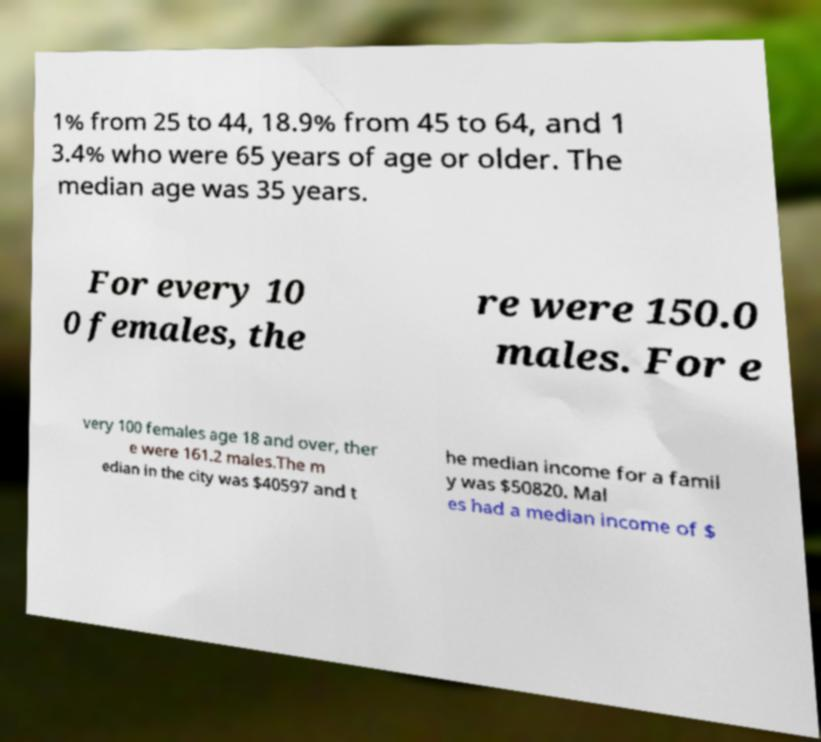There's text embedded in this image that I need extracted. Can you transcribe it verbatim? 1% from 25 to 44, 18.9% from 45 to 64, and 1 3.4% who were 65 years of age or older. The median age was 35 years. For every 10 0 females, the re were 150.0 males. For e very 100 females age 18 and over, ther e were 161.2 males.The m edian in the city was $40597 and t he median income for a famil y was $50820. Mal es had a median income of $ 